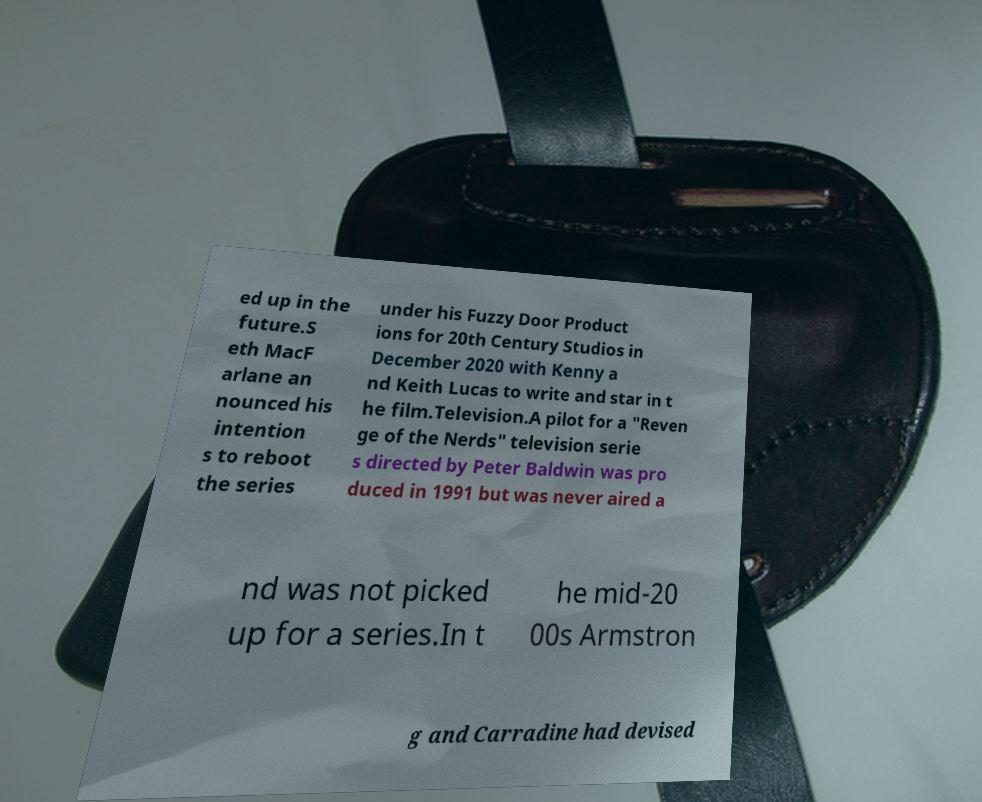Please read and relay the text visible in this image. What does it say? ed up in the future.S eth MacF arlane an nounced his intention s to reboot the series under his Fuzzy Door Product ions for 20th Century Studios in December 2020 with Kenny a nd Keith Lucas to write and star in t he film.Television.A pilot for a "Reven ge of the Nerds" television serie s directed by Peter Baldwin was pro duced in 1991 but was never aired a nd was not picked up for a series.In t he mid-20 00s Armstron g and Carradine had devised 